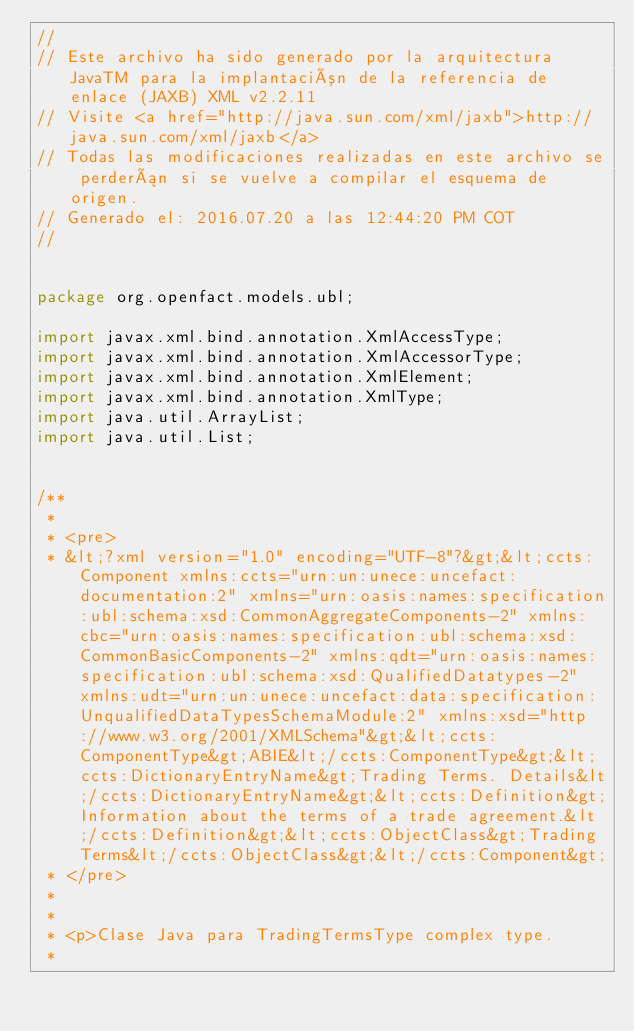Convert code to text. <code><loc_0><loc_0><loc_500><loc_500><_Java_>//
// Este archivo ha sido generado por la arquitectura JavaTM para la implantación de la referencia de enlace (JAXB) XML v2.2.11 
// Visite <a href="http://java.sun.com/xml/jaxb">http://java.sun.com/xml/jaxb</a> 
// Todas las modificaciones realizadas en este archivo se perderán si se vuelve a compilar el esquema de origen. 
// Generado el: 2016.07.20 a las 12:44:20 PM COT 
//


package org.openfact.models.ubl;

import javax.xml.bind.annotation.XmlAccessType;
import javax.xml.bind.annotation.XmlAccessorType;
import javax.xml.bind.annotation.XmlElement;
import javax.xml.bind.annotation.XmlType;
import java.util.ArrayList;
import java.util.List;


/**
 * 
 * <pre>
 * &lt;?xml version="1.0" encoding="UTF-8"?&gt;&lt;ccts:Component xmlns:ccts="urn:un:unece:uncefact:documentation:2" xmlns="urn:oasis:names:specification:ubl:schema:xsd:CommonAggregateComponents-2" xmlns:cbc="urn:oasis:names:specification:ubl:schema:xsd:CommonBasicComponents-2" xmlns:qdt="urn:oasis:names:specification:ubl:schema:xsd:QualifiedDatatypes-2" xmlns:udt="urn:un:unece:uncefact:data:specification:UnqualifiedDataTypesSchemaModule:2" xmlns:xsd="http://www.w3.org/2001/XMLSchema"&gt;&lt;ccts:ComponentType&gt;ABIE&lt;/ccts:ComponentType&gt;&lt;ccts:DictionaryEntryName&gt;Trading Terms. Details&lt;/ccts:DictionaryEntryName&gt;&lt;ccts:Definition&gt;Information about the terms of a trade agreement.&lt;/ccts:Definition&gt;&lt;ccts:ObjectClass&gt;Trading Terms&lt;/ccts:ObjectClass&gt;&lt;/ccts:Component&gt;
 * </pre>
 *
 * 
 * <p>Clase Java para TradingTermsType complex type.
 * </code> 